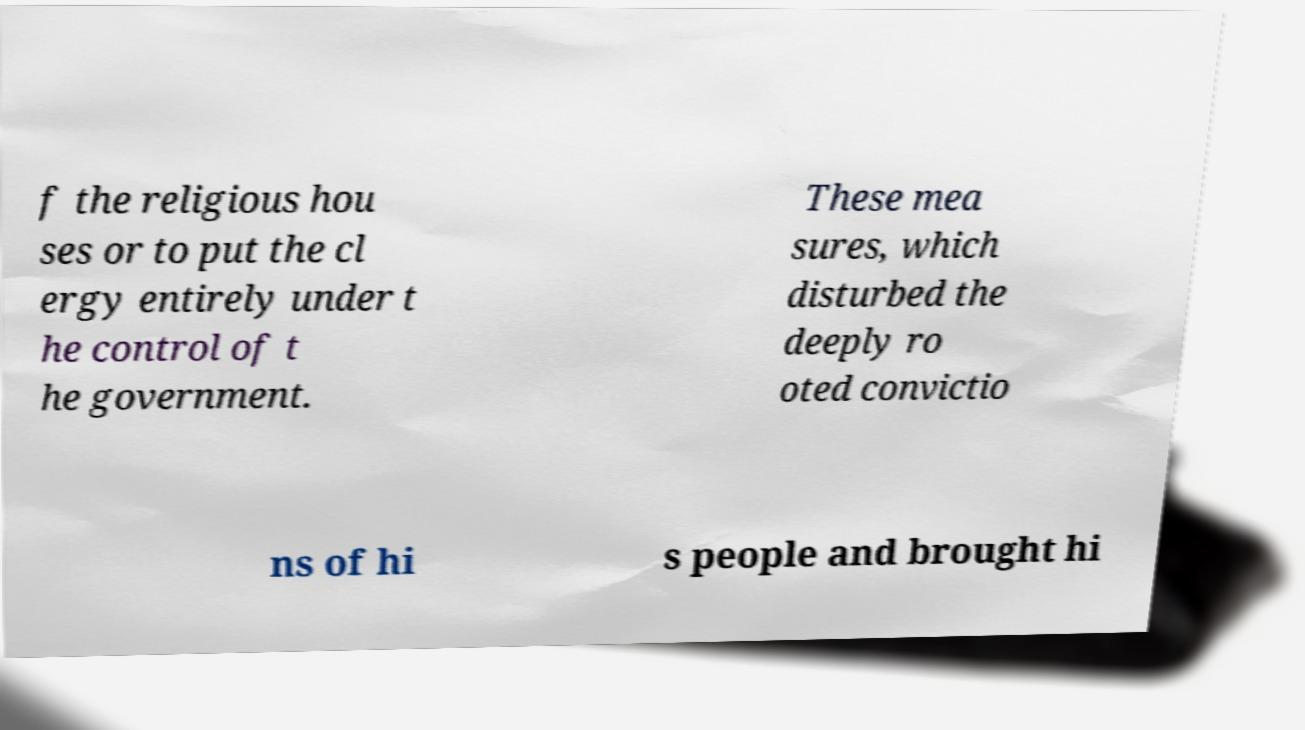I need the written content from this picture converted into text. Can you do that? f the religious hou ses or to put the cl ergy entirely under t he control of t he government. These mea sures, which disturbed the deeply ro oted convictio ns of hi s people and brought hi 